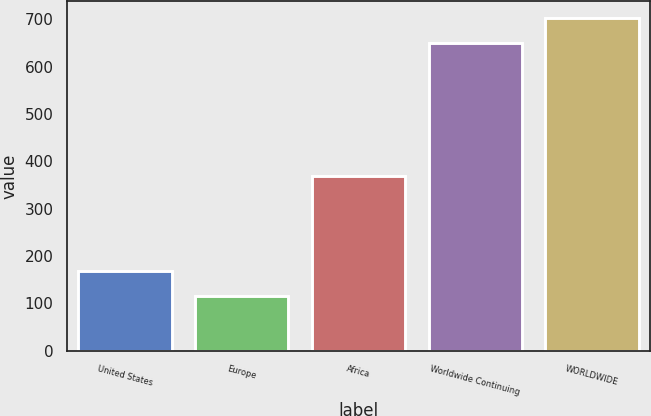Convert chart to OTSL. <chart><loc_0><loc_0><loc_500><loc_500><bar_chart><fcel>United States<fcel>Europe<fcel>Africa<fcel>Worldwide Continuing<fcel>WORLDWIDE<nl><fcel>168.5<fcel>115<fcel>369<fcel>650<fcel>703.5<nl></chart> 